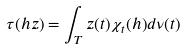<formula> <loc_0><loc_0><loc_500><loc_500>\tau ( h z ) = \int _ { T } z ( t ) \chi _ { t } ( h ) d \nu ( t )</formula> 